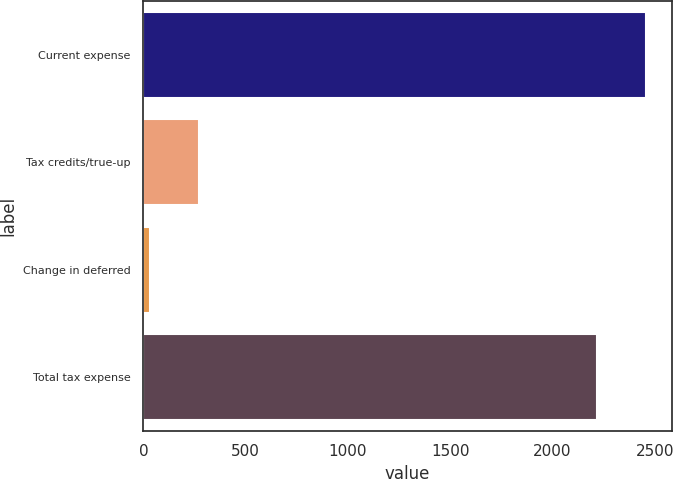Convert chart. <chart><loc_0><loc_0><loc_500><loc_500><bar_chart><fcel>Current expense<fcel>Tax credits/true-up<fcel>Change in deferred<fcel>Total tax expense<nl><fcel>2458.4<fcel>271.4<fcel>32<fcel>2219<nl></chart> 